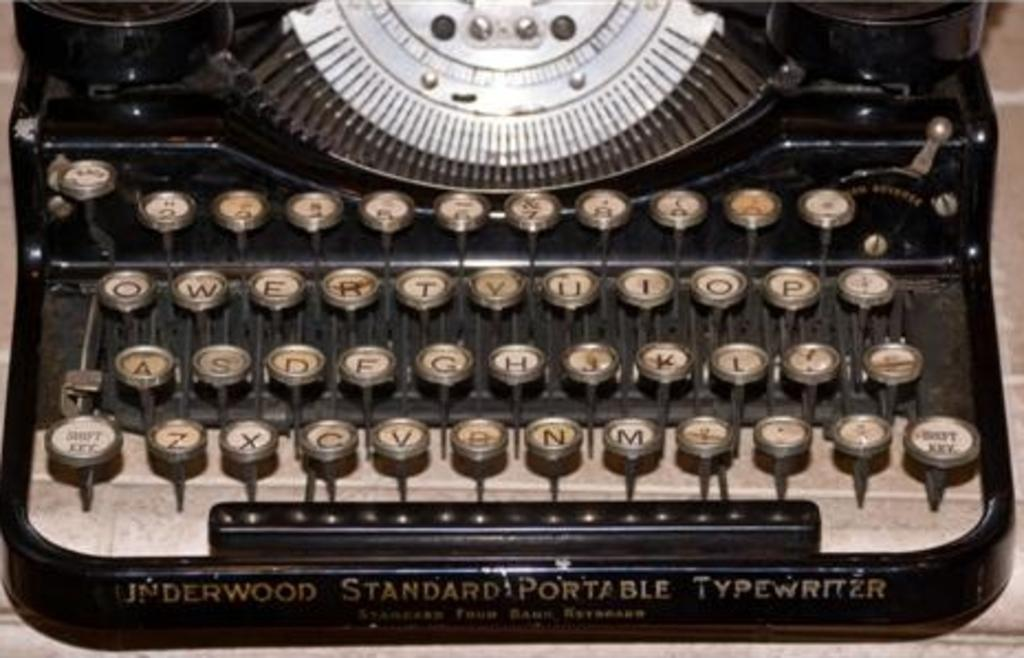<image>
Present a compact description of the photo's key features. The keyboard of an Underwood Standard Portable Typewriter. 